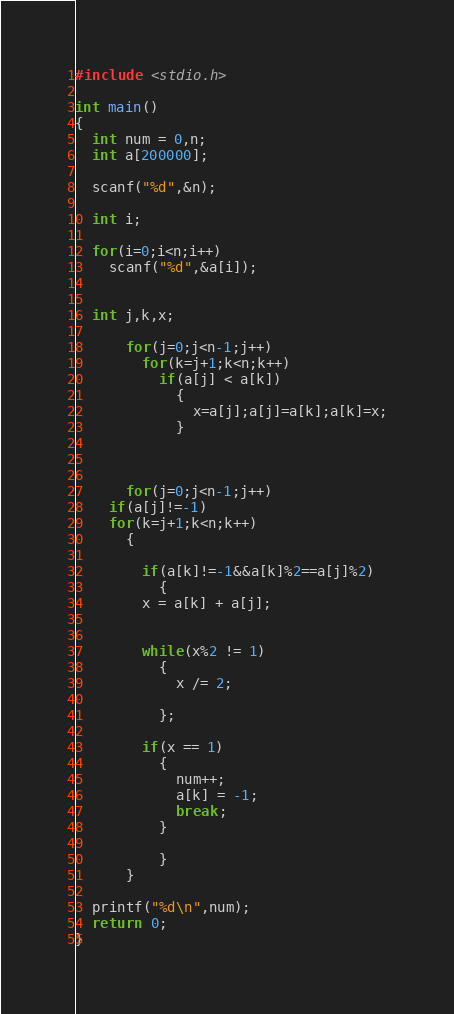Convert code to text. <code><loc_0><loc_0><loc_500><loc_500><_C_>#include <stdio.h>

int main()
{
  int num = 0,n;
  int a[200000];

  scanf("%d",&n);

  int i;

  for(i=0;i<n;i++)
    scanf("%d",&a[i]);


  int j,k,x;

      for(j=0;j<n-1;j++)
      	for(k=j+1;k<n;k++)
      	  if(a[j] < a[k])
      	    {
      	      x=a[j];a[j]=a[k];a[k]=x;
      	    }


      
      for(j=0;j<n-1;j++)
	if(a[j]!=-1)
	for(k=j+1;k<n;k++)
	  {
	    
	    if(a[k]!=-1&&a[k]%2==a[j]%2)
	      {
		x = a[k] + a[j];


		while(x%2 != 1)
		  {
		    x /= 2;
      
		  };

		if(x == 1)
		  {
		    num++;
		    a[k] = -1;
		    break;
		  }
	    
	      }
	  }

  printf("%d\n",num);
  return 0;
}

</code> 